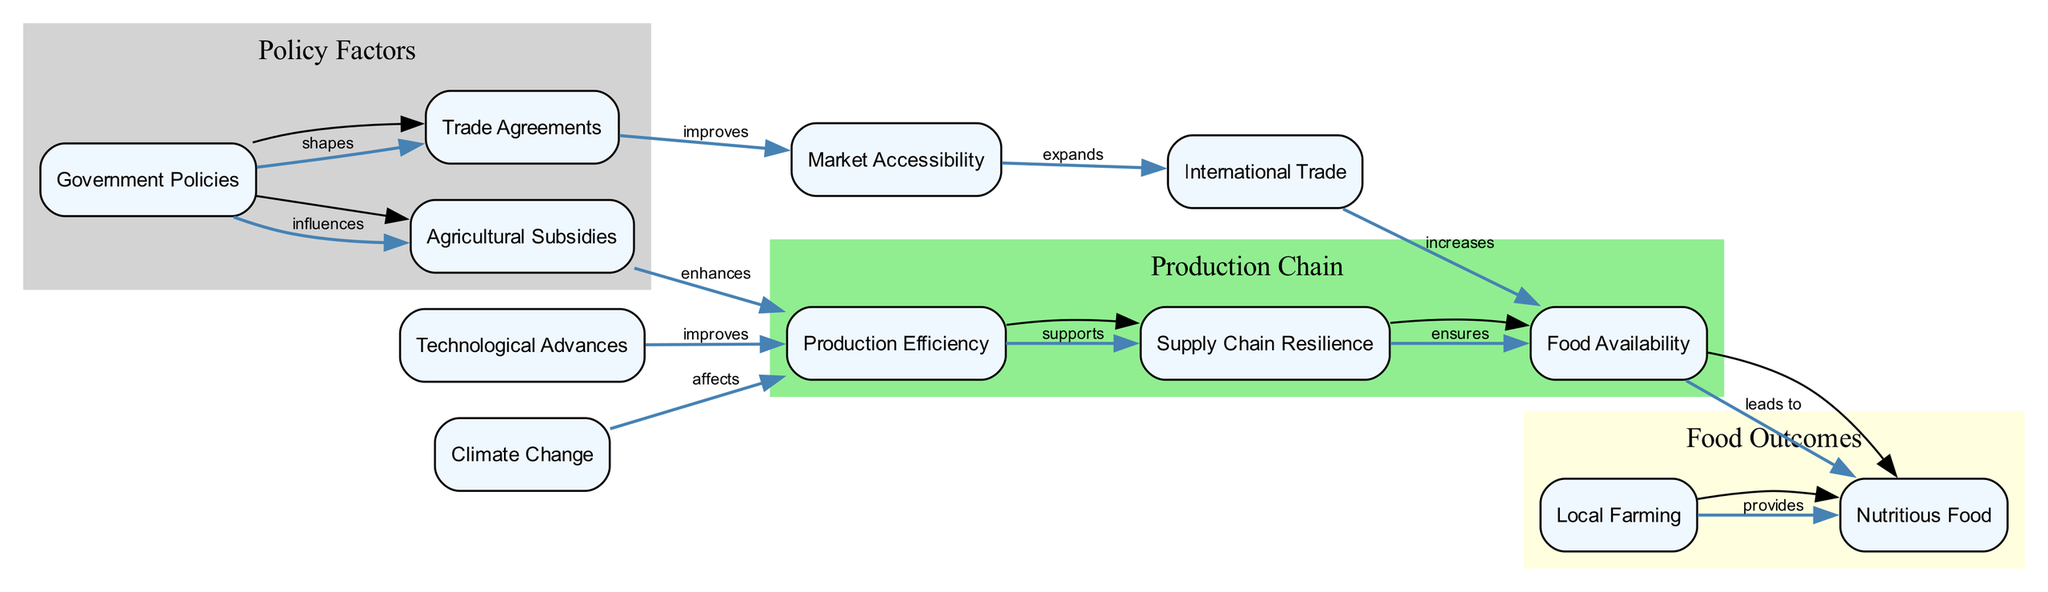What is the main influence of Government Policies? The main influence of Government Policies is seen in its connection to Agricultural Subsidies and Trade Agreements. The diagram clearly indicates that Government Policies "influence" Agricultural Subsidies and "shapes" Trade Agreements.
Answer: Agricultural Subsidies, Trade Agreements How many nodes are there in the diagram? The diagram consists of a list of nodes depicting various elements related to food security strategies. By counting the unique labels in the data, we find there are 12 distinct nodes.
Answer: 12 What factor improves Production Efficiency? In the diagram, it is indicated that both Agricultural Subsidies and Technological Advances have a direct relationship with Production Efficiency. Agricultural Subsidies "enhance" Production Efficiency while Technological Advances "improve" it.
Answer: Agricultural Subsidies, Technological Advances What does Supply Chain Resilience ensure? According to the diagram, Supply Chain Resilience has a direct influence on Food Availability. The relationship is depicted with the edge labeled "ensures", signifying that resilient supply chains are crucial for ensuring the availability of food.
Answer: Food Availability What type of farming provides Nutritious Food? The diagram indicates that Local Farming is the source that "provides" Nutritious Food. This relationship is explicitly represented in the edges of the diagram.
Answer: Local Farming Which nodes contribute to Market Accessibility? The diagram shows that Trade Agreements improve Market Accessibility. There is a clear connection marked with the label "improves", indicating that Trade Agreements play a significant role in enhancing market accessibility for food products.
Answer: Trade Agreements How is Food Availability affected by International Trade? The diagram illustrates that International Trade directly increases Food Availability. The edge connecting them is labeled "increases," indicating a positive impact of international trade on the availability of food.
Answer: Increases Which two nodes are grouped under Policy Factors? In the diagram, the nodes that are categorized under Policy Factors are Government Policies and Agricultural Subsidies. These nodes are clustered and differentiated visually according to their relation to policy-making.
Answer: Government Policies, Agricultural Subsidies Which node has the primary effect of Climate Change? The diagram shows that Climate Change impacts Production Efficiency negatively. This is highlighted with the line labeled "affects," indicating that climate-related factors can reduce the efficiency of food production systems.
Answer: Production Efficiency 